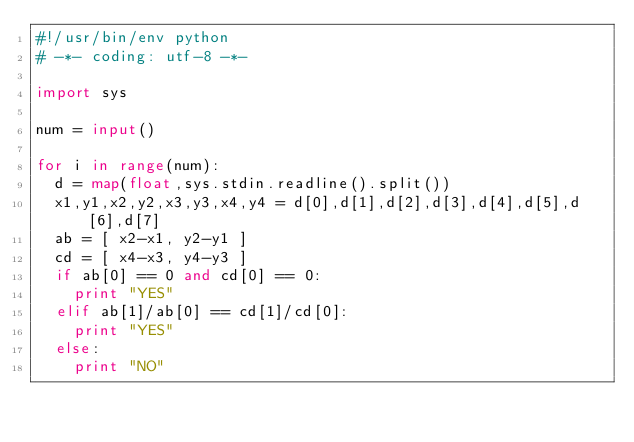<code> <loc_0><loc_0><loc_500><loc_500><_Python_>#!/usr/bin/env python
# -*- coding: utf-8 -*-

import sys

num = input()

for i in range(num):
  d = map(float,sys.stdin.readline().split())
  x1,y1,x2,y2,x3,y3,x4,y4 = d[0],d[1],d[2],d[3],d[4],d[5],d[6],d[7]
  ab = [ x2-x1, y2-y1 ]
  cd = [ x4-x3, y4-y3 ]
  if ab[0] == 0 and cd[0] == 0:
    print "YES"
  elif ab[1]/ab[0] == cd[1]/cd[0]:
    print "YES"
  else:
    print "NO"</code> 